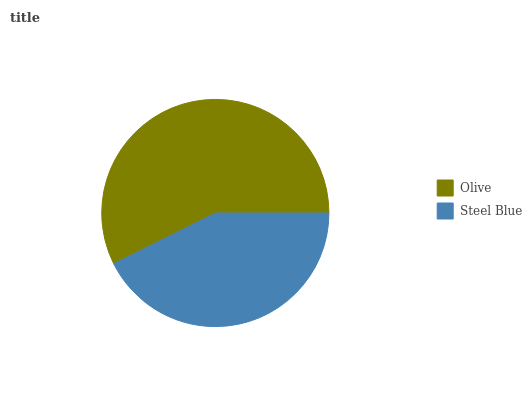Is Steel Blue the minimum?
Answer yes or no. Yes. Is Olive the maximum?
Answer yes or no. Yes. Is Steel Blue the maximum?
Answer yes or no. No. Is Olive greater than Steel Blue?
Answer yes or no. Yes. Is Steel Blue less than Olive?
Answer yes or no. Yes. Is Steel Blue greater than Olive?
Answer yes or no. No. Is Olive less than Steel Blue?
Answer yes or no. No. Is Olive the high median?
Answer yes or no. Yes. Is Steel Blue the low median?
Answer yes or no. Yes. Is Steel Blue the high median?
Answer yes or no. No. Is Olive the low median?
Answer yes or no. No. 